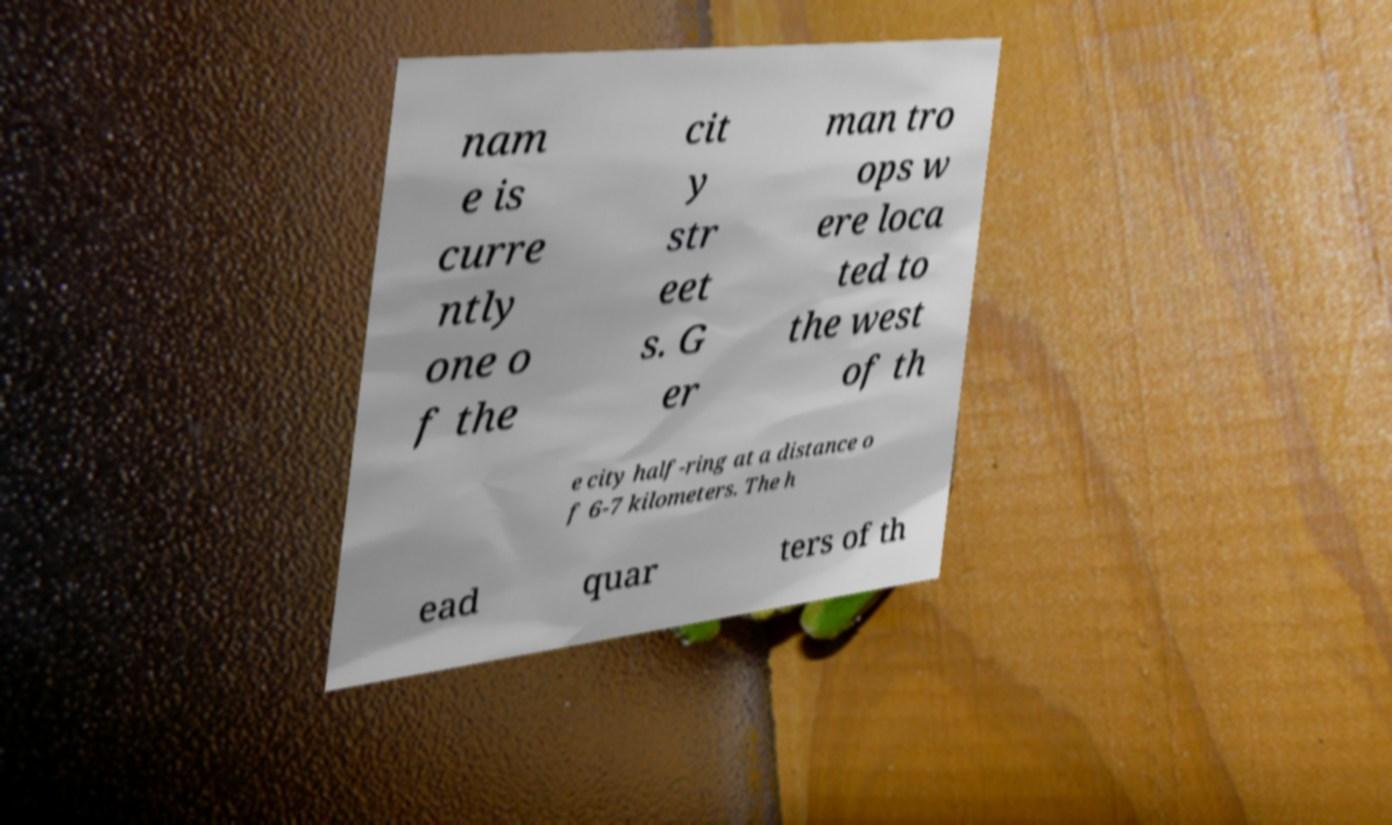Can you read and provide the text displayed in the image?This photo seems to have some interesting text. Can you extract and type it out for me? nam e is curre ntly one o f the cit y str eet s. G er man tro ops w ere loca ted to the west of th e city half-ring at a distance o f 6-7 kilometers. The h ead quar ters of th 